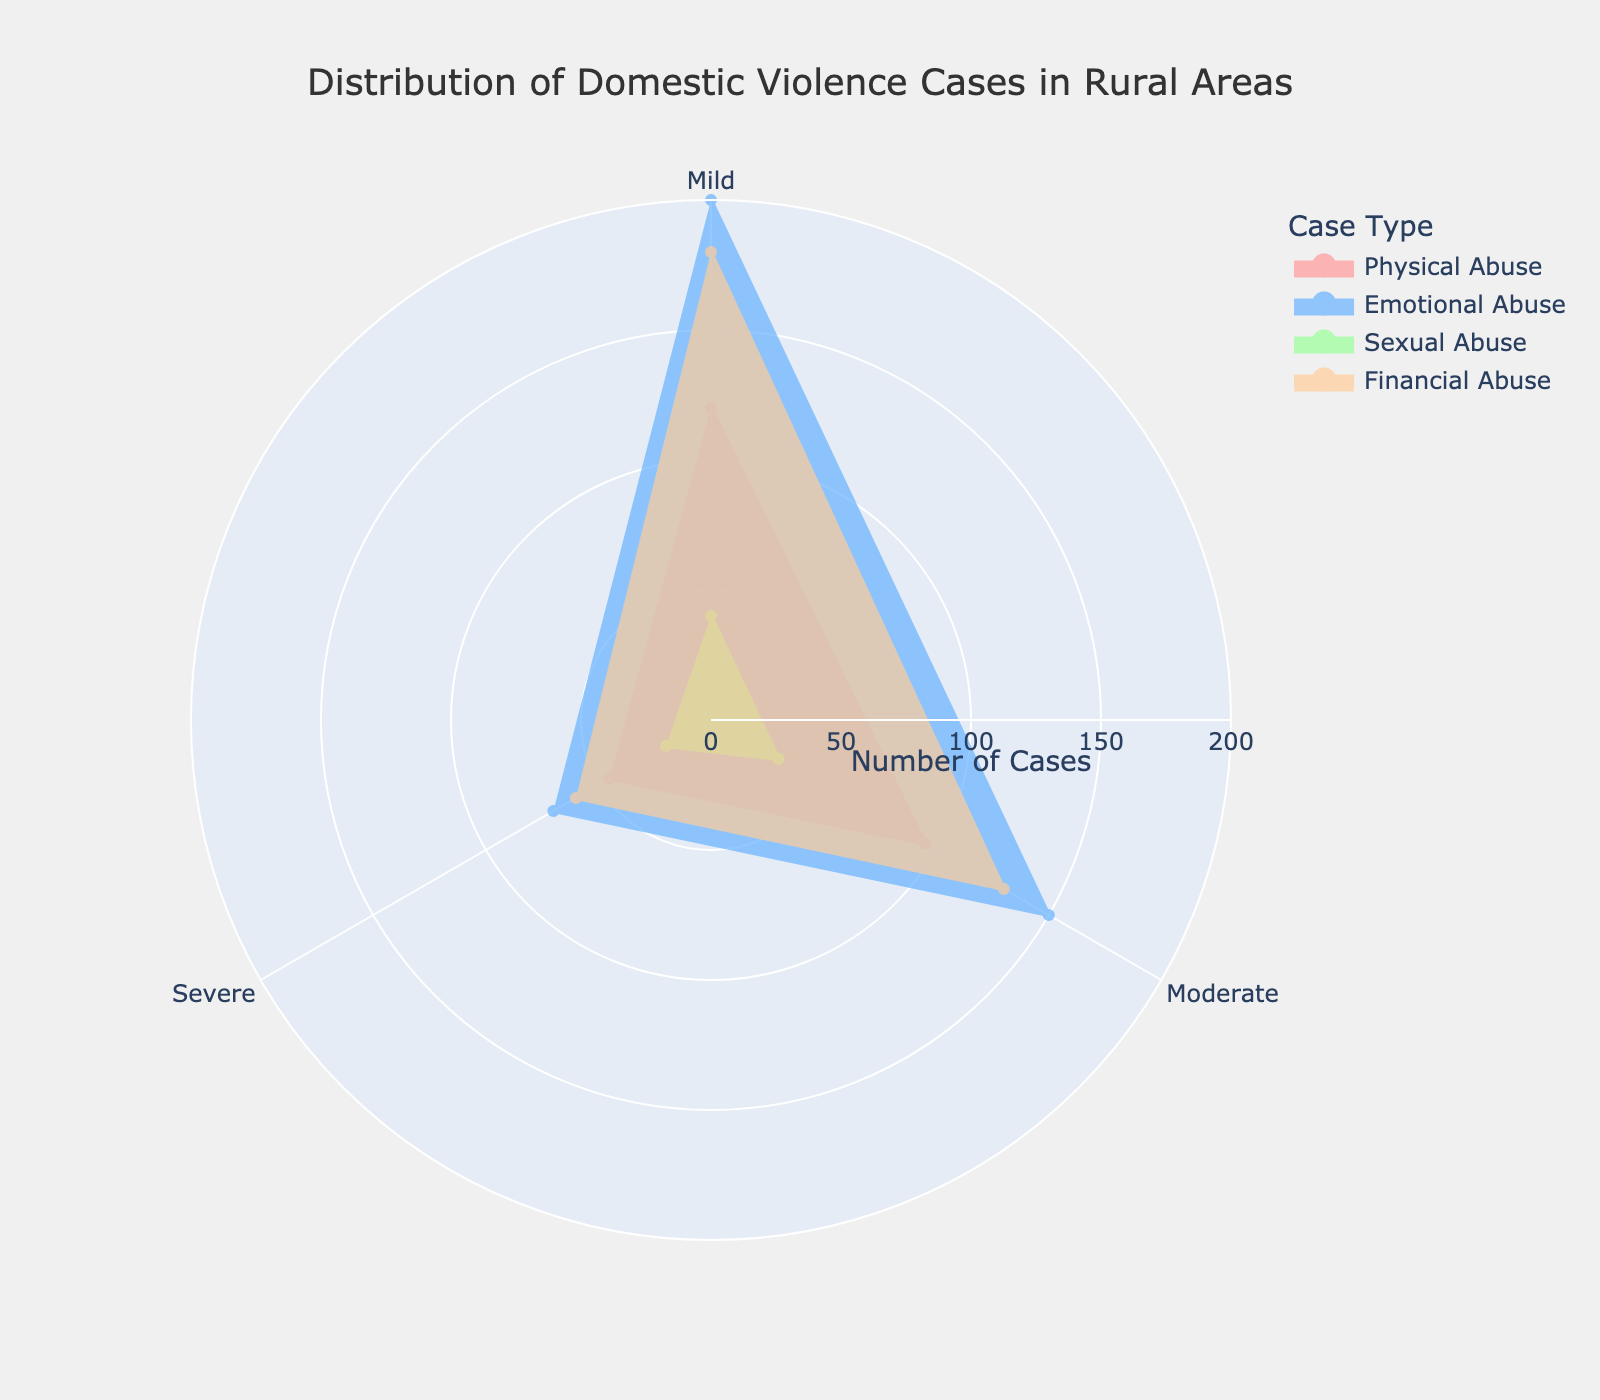What is the title of the plot? The title of the plot is displayed at the top-center of the figure. It provides a summary of what the chart is about.
Answer: Distribution of Domestic Violence Cases in Rural Areas Which case type has the highest number of mild cases? By observing the radial lines extending from the center, the case type with the outermost point for the mild severity indicates the highest count.
Answer: Emotional Abuse What is the total number of severe cases across all types of abuse? Sum the number of severe cases for each abuse type: Physical Abuse (45) + Emotional Abuse (70) + Sexual Abuse (20) + Financial Abuse (60).
Answer: 195 Compare the number of moderate cases of Physical Abuse and Financial Abuse. Which one is greater? Look at the radial lines for the moderate severity; compare the lengths for Physical Abuse and Financial Abuse.
Answer: Physical Abuse How does the number of severe cases of Sexual Abuse compare to mild cases of the same type? Check the radial lines for Sexual Abuse; compare the lengths for severe and mild severities.
Answer: Mild cases are higher Which severity level has the smallest range of counts across different case types? Examine the spread of points for each severity level (mild, moderate, severe) and identify which one shows the smallest range from minimum to maximum.
Answer: Severe Order the abuse types from the highest to the lowest total number of cases. Sum the counts for each abuse type: Physical Abuse (120+95+45), Emotional Abuse (200+150+70), Sexual Abuse (40+30+20), and Financial Abuse (180+130+60).
Answer: Emotional Abuse, Financial Abuse, Physical Abuse, Sexual Abuse What is the combined count of moderate cases for Emotional Abuse and Financial Abuse? Add the counts for moderate severity of Emotional Abuse (150) and Financial Abuse (130).
Answer: 280 Which abuse type has the most even distribution across the severities? Look at the shapes of the filled areas for each abuse type; the most even distribution would show a more regular, balanced shape.
Answer: Financial Abuse Compare the number of mild cases of Financial Abuse to severe cases of Emotional Abuse. Which is higher? Look at the radial line lengths for Financial Abuse under mild severity and Emotional Abuse under severe severity and compare their lengths.
Answer: Mild cases of Financial Abuse 